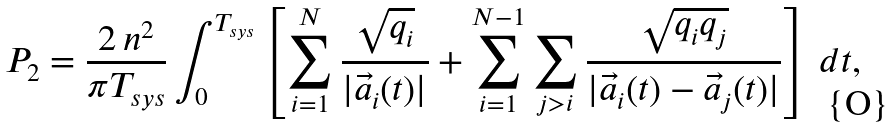<formula> <loc_0><loc_0><loc_500><loc_500>P _ { 2 } = \frac { 2 \, n ^ { 2 } } { \pi T _ { s y s } } \int _ { 0 } ^ { T _ { s y s } } \left [ \sum _ { i = 1 } ^ { N } \frac { \sqrt { q _ { i } } } { | \vec { a } _ { i } ( t ) | } + \sum _ { i = 1 } ^ { N - 1 } \sum _ { j > i } \frac { \sqrt { q _ { i } q _ { j } } } { | \vec { a } _ { i } ( t ) - \vec { a } _ { j } ( t ) | } \right ] \, d t ,</formula> 